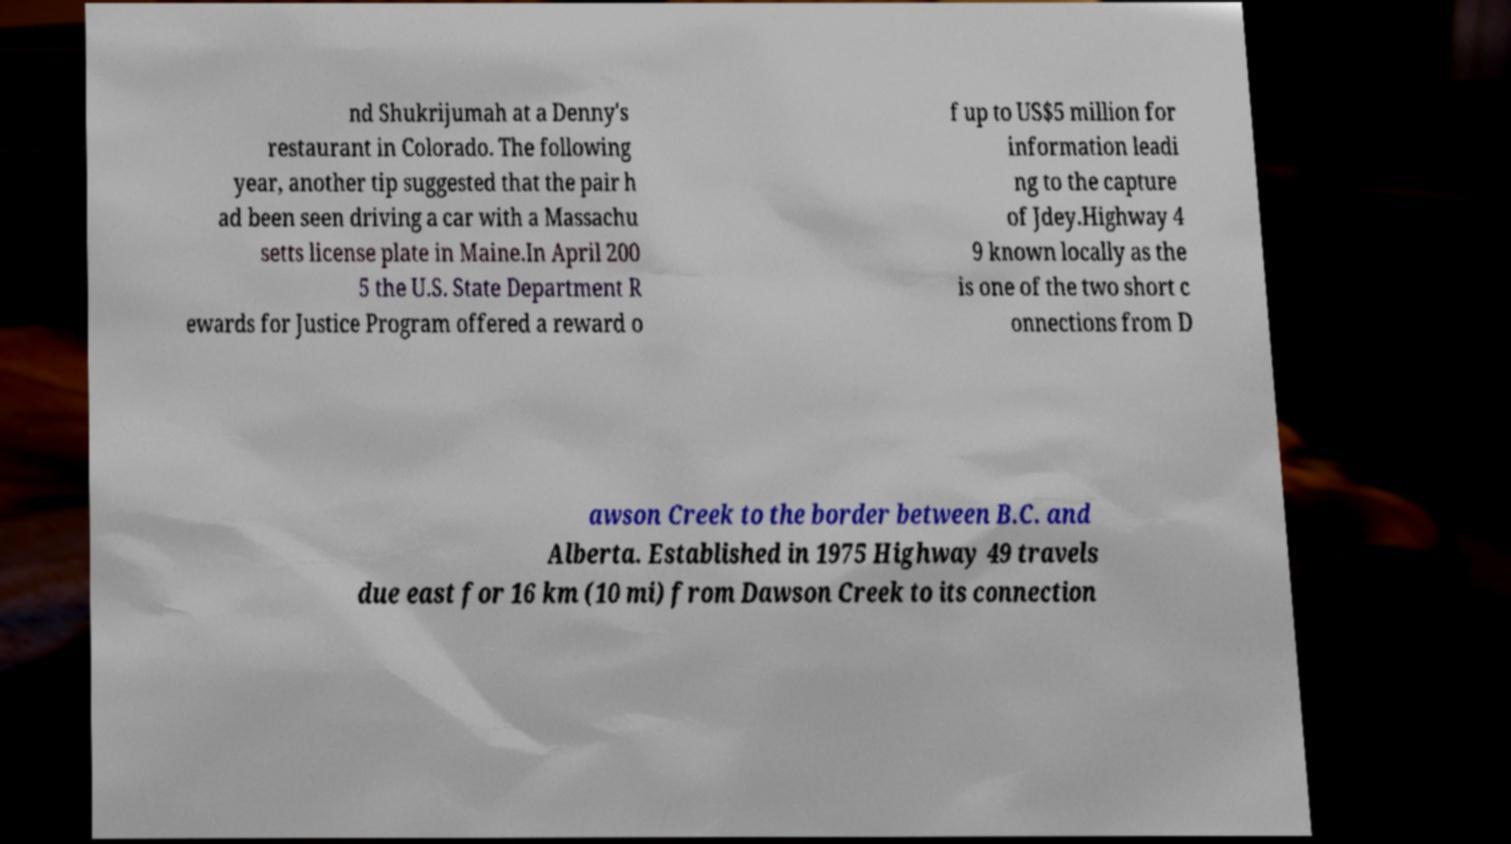There's text embedded in this image that I need extracted. Can you transcribe it verbatim? nd Shukrijumah at a Denny's restaurant in Colorado. The following year, another tip suggested that the pair h ad been seen driving a car with a Massachu setts license plate in Maine.In April 200 5 the U.S. State Department R ewards for Justice Program offered a reward o f up to US$5 million for information leadi ng to the capture of Jdey.Highway 4 9 known locally as the is one of the two short c onnections from D awson Creek to the border between B.C. and Alberta. Established in 1975 Highway 49 travels due east for 16 km (10 mi) from Dawson Creek to its connection 